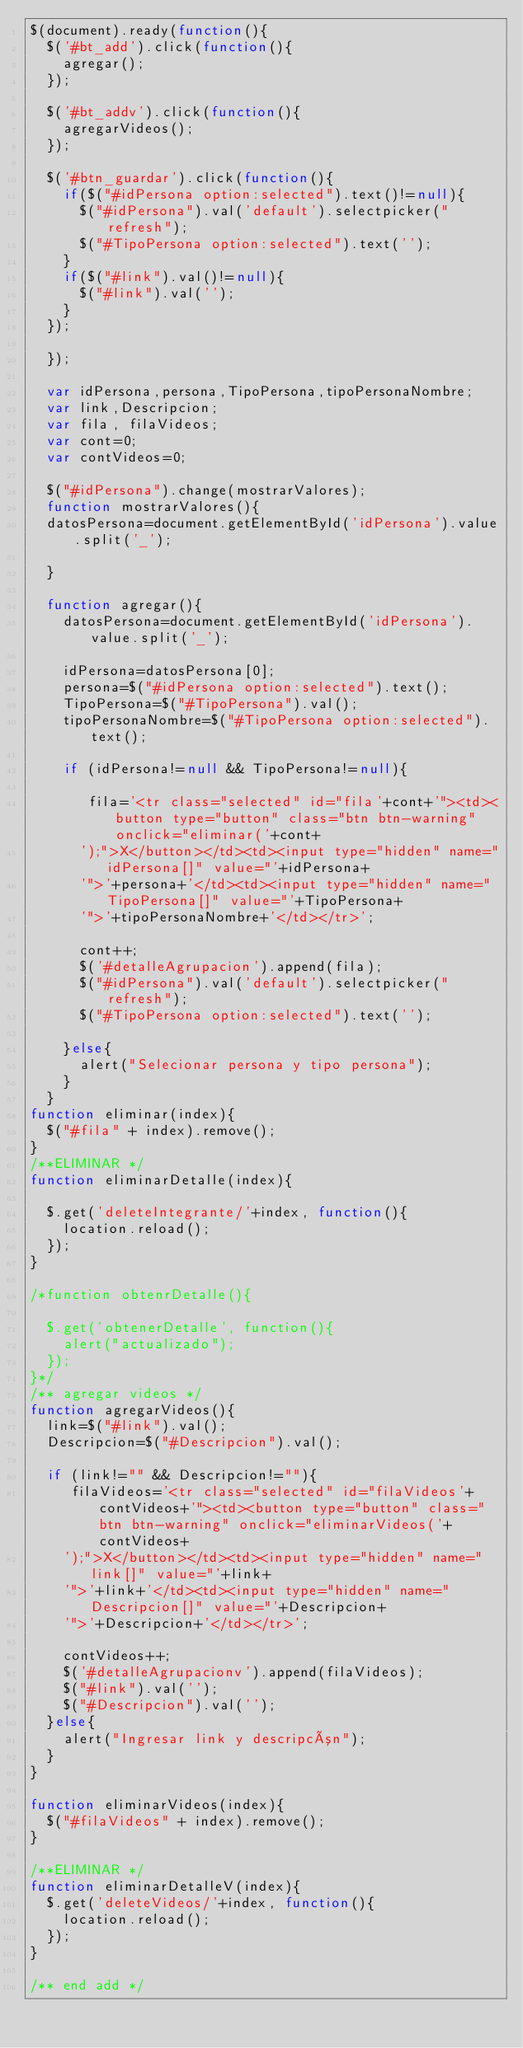<code> <loc_0><loc_0><loc_500><loc_500><_JavaScript_>$(document).ready(function(){
	$('#bt_add').click(function(){
		agregar();
	});

	$('#bt_addv').click(function(){
		agregarVideos();
	});
	
	$('#btn_guardar').click(function(){
		if($("#idPersona option:selected").text()!=null){
			$("#idPersona").val('default').selectpicker("refresh");
			$("#TipoPersona option:selected").text('');
		}
		if($("#link").val()!=null){
			$("#link").val('');
		}
	});

	});

	var idPersona,persona,TipoPersona,tipoPersonaNombre;
	var link,Descripcion;
	var fila, filaVideos;
	var cont=0;
	var contVideos=0;	

	$("#idPersona").change(mostrarValores);	
	function mostrarValores(){
	datosPersona=document.getElementById('idPersona').value.split('_');
	
	}
	
	function agregar(){
		datosPersona=document.getElementById('idPersona').value.split('_');
	
		idPersona=datosPersona[0];
		persona=$("#idPersona option:selected").text();
		TipoPersona=$("#TipoPersona").val();
		tipoPersonaNombre=$("#TipoPersona option:selected").text();
	
		if (idPersona!=null && TipoPersona!=null){
			
			 fila='<tr class="selected" id="fila'+cont+'"><td><button type="button" class="btn btn-warning" onclick="eliminar('+cont+
			');">X</button></td><td><input type="hidden" name="idPersona[]" value="'+idPersona+
			'">'+persona+'</td><td><input type="hidden" name="TipoPersona[]" value="'+TipoPersona+
			'">'+tipoPersonaNombre+'</td></tr>';	
			
			cont++;			
			$('#detalleAgrupacion').append(fila);				
			$("#idPersona").val('default').selectpicker("refresh");
			$("#TipoPersona option:selected").text('');

		}else{
			alert("Selecionar persona y tipo persona");
		}
	}
function eliminar(index){   		 
	$("#fila" + index).remove();
}
/**ELIMINAR */
function eliminarDetalle(index){
	
	$.get('deleteIntegrante/'+index, function(){		
		location.reload();
	});
}

/*function obtenrDetalle(){
	
	$.get('obtenerDetalle', function(){		
		alert("actualizado");
	});
}*/
/** agregar videos */
function agregarVideos(){	
	link=$("#link").val();
	Descripcion=$("#Descripcion").val();

	if (link!="" && Descripcion!=""){		
		 filaVideos='<tr class="selected" id="filaVideos'+contVideos+'"><td><button type="button" class="btn btn-warning" onclick="eliminarVideos('+contVideos+
		');">X</button></td><td><input type="hidden" name="link[]" value="'+link+
		'">'+link+'</td><td><input type="hidden" name="Descripcion[]" value="'+Descripcion+
		'">'+Descripcion+'</td></tr>';	
		
		contVideos++;			
		$('#detalleAgrupacionv').append(filaVideos);
		$("#link").val('');
		$("#Descripcion").val('');
	}else{
		alert("Ingresar link y descripcón");
	}
}

function eliminarVideos(index){   		 
	$("#filaVideos" + index).remove();
}

/**ELIMINAR */
function eliminarDetalleV(index){	
	$.get('deleteVideos/'+index, function(){		
		location.reload();
	});
}

/** end add */

	</code> 